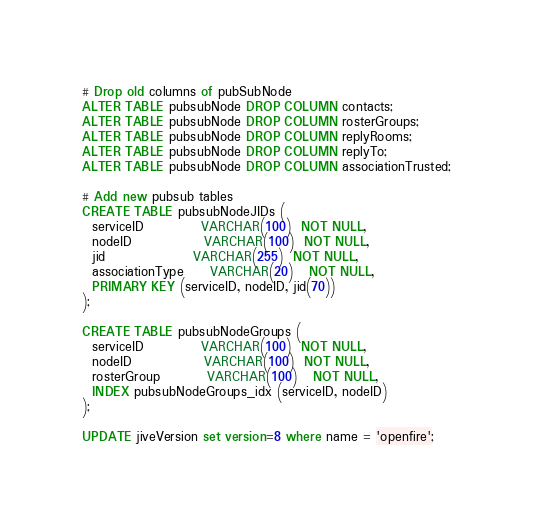Convert code to text. <code><loc_0><loc_0><loc_500><loc_500><_SQL_>
# Drop old columns of pubSubNode
ALTER TABLE pubsubNode DROP COLUMN contacts;
ALTER TABLE pubsubNode DROP COLUMN rosterGroups;
ALTER TABLE pubsubNode DROP COLUMN replyRooms;
ALTER TABLE pubsubNode DROP COLUMN replyTo;
ALTER TABLE pubsubNode DROP COLUMN associationTrusted;

# Add new pubsub tables
CREATE TABLE pubsubNodeJIDs (
  serviceID           VARCHAR(100)  NOT NULL,
  nodeID              VARCHAR(100)  NOT NULL,
  jid                 VARCHAR(255)  NOT NULL,
  associationType     VARCHAR(20)   NOT NULL,
  PRIMARY KEY (serviceID, nodeID, jid(70))
);

CREATE TABLE pubsubNodeGroups (
  serviceID           VARCHAR(100)  NOT NULL,
  nodeID              VARCHAR(100)  NOT NULL,
  rosterGroup         VARCHAR(100)   NOT NULL,
  INDEX pubsubNodeGroups_idx (serviceID, nodeID)
);

UPDATE jiveVersion set version=8 where name = 'openfire';
</code> 